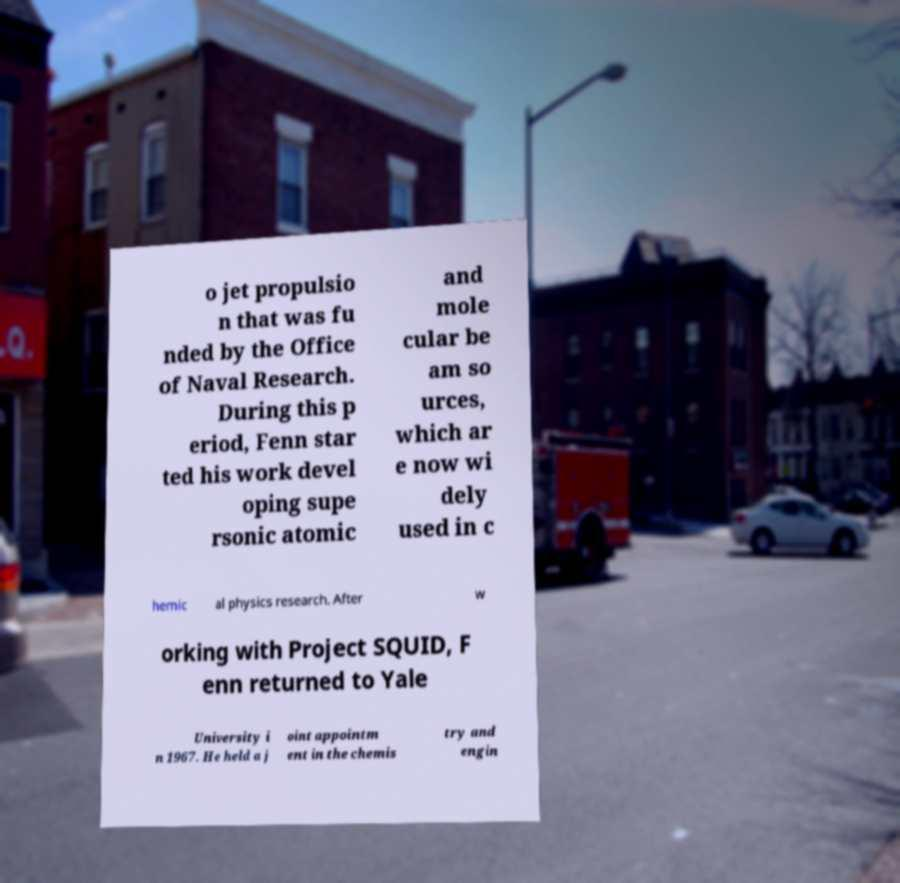I need the written content from this picture converted into text. Can you do that? o jet propulsio n that was fu nded by the Office of Naval Research. During this p eriod, Fenn star ted his work devel oping supe rsonic atomic and mole cular be am so urces, which ar e now wi dely used in c hemic al physics research. After w orking with Project SQUID, F enn returned to Yale University i n 1967. He held a j oint appointm ent in the chemis try and engin 